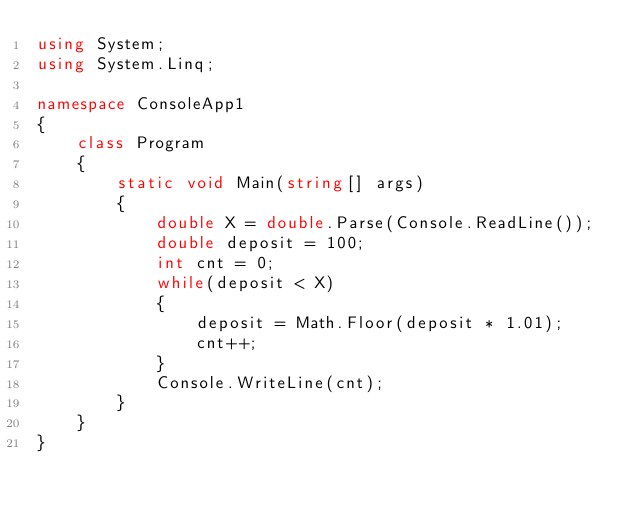Convert code to text. <code><loc_0><loc_0><loc_500><loc_500><_C#_>using System;
using System.Linq;

namespace ConsoleApp1
{
    class Program
    {
        static void Main(string[] args)
        {
            double X = double.Parse(Console.ReadLine());
            double deposit = 100;
            int cnt = 0;
            while(deposit < X)
            {
                deposit = Math.Floor(deposit * 1.01);
                cnt++;
            }
            Console.WriteLine(cnt);
        }
    }
}</code> 